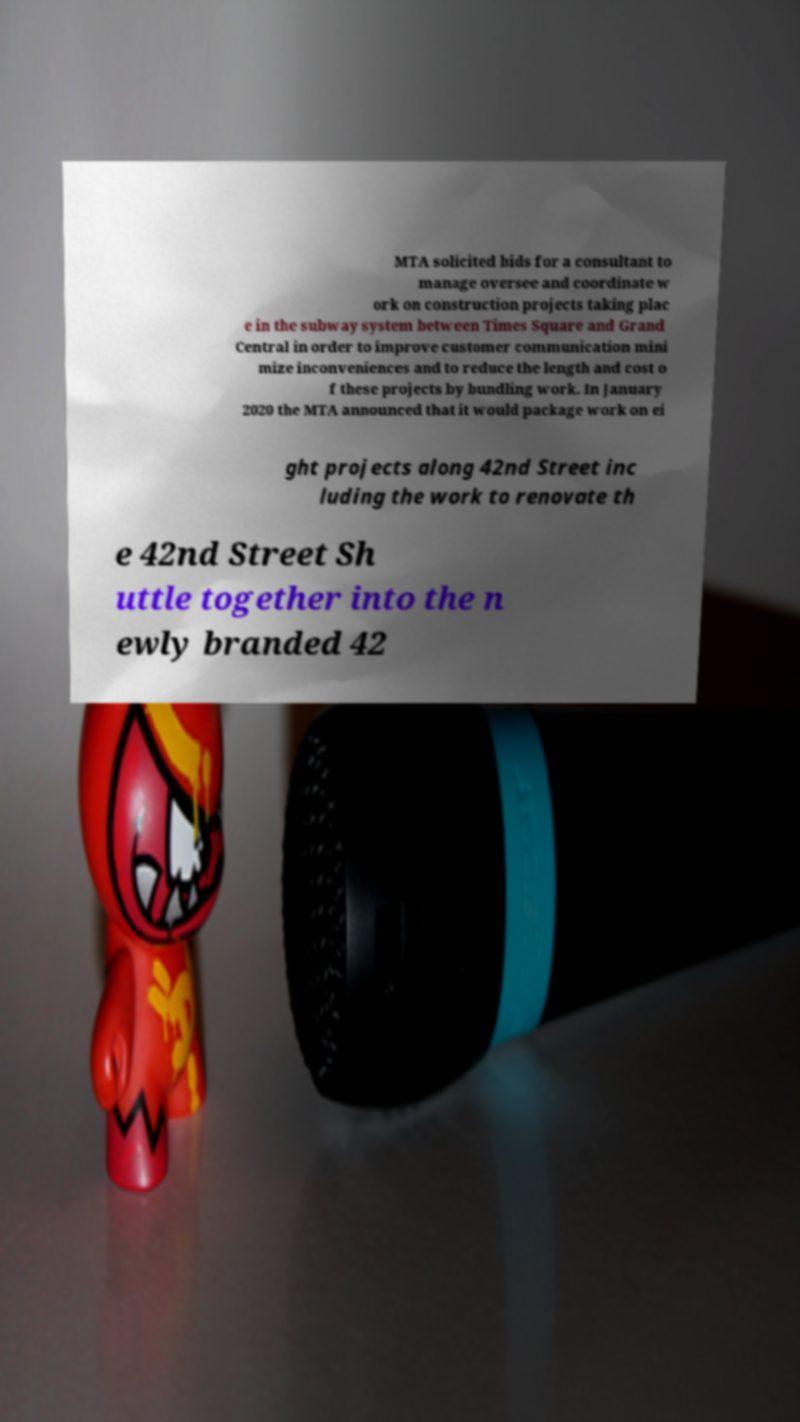Could you extract and type out the text from this image? MTA solicited bids for a consultant to manage oversee and coordinate w ork on construction projects taking plac e in the subway system between Times Square and Grand Central in order to improve customer communication mini mize inconveniences and to reduce the length and cost o f these projects by bundling work. In January 2020 the MTA announced that it would package work on ei ght projects along 42nd Street inc luding the work to renovate th e 42nd Street Sh uttle together into the n ewly branded 42 